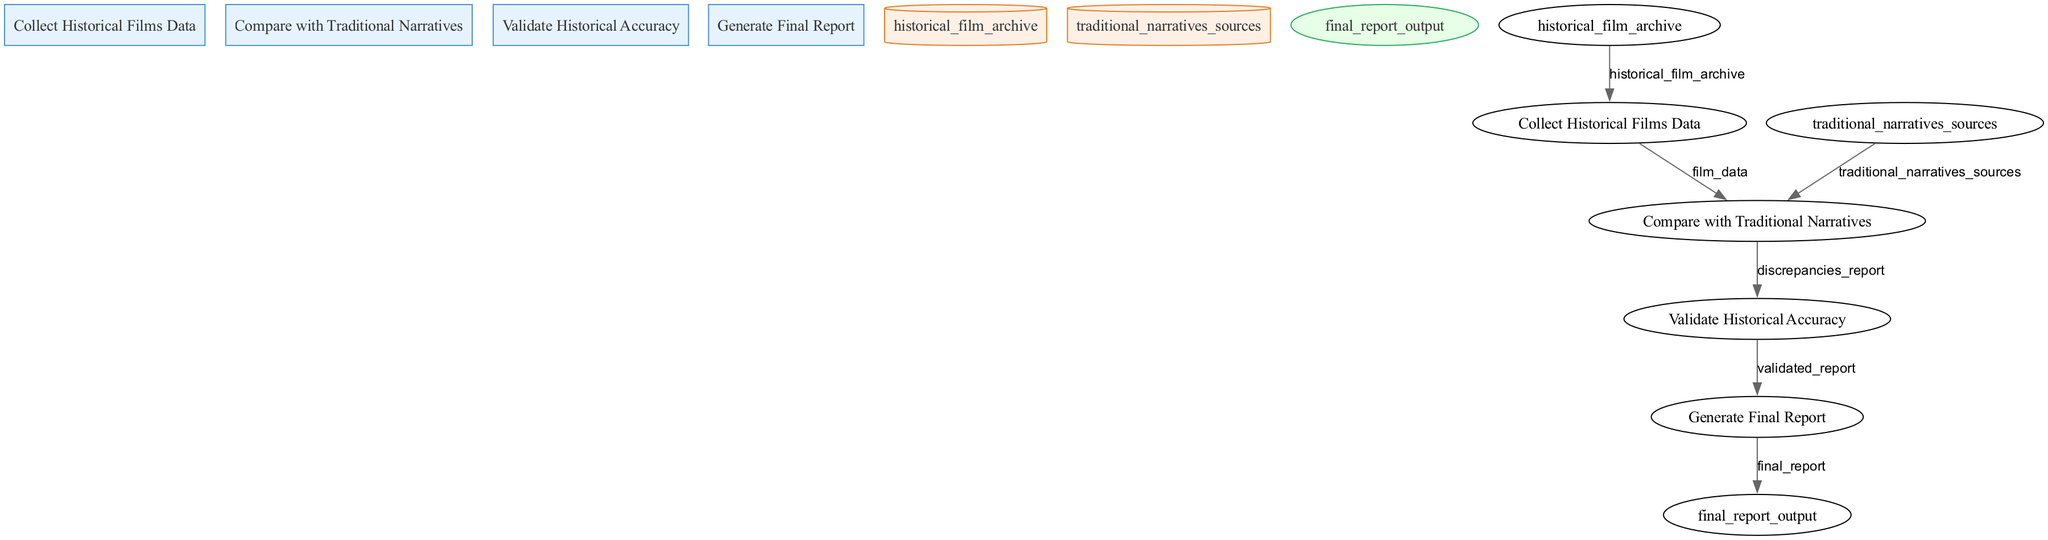What is the output of process 3? Process 3, "Validate Historical Accuracy," produces an output termed "validated_report." This is the result of checking discrepancies found in the previous step for historical accuracy.
Answer: validated_report How many data stores are present in the diagram? The diagram contains two data stores: "historical_film_archive" and "traditional_narratives_sources." These are the locations where data is stored for processing.
Answer: 2 What is the input for process 2? Process 2, "Compare with Traditional Narratives," requires two inputs: "film_data," which comes from process 1, and "traditional_narratives_sources," which is the data store.
Answer: film_data and traditional_narratives_sources Which process generates the final report? The final report is generated by process 4, "Generate Final Report," which compiles information from the validated report created in process 3.
Answer: Generate Final Report What type of node is "historical_film_archive"? "historical_film_archive" is categorized as a data store, indicated by its cylindrical shape in the diagram. This store holds information on historical films.
Answer: data store What would you find in the validated report? The validated report contains the results of the validation process, which assesses the accuracy of historical films against traditional narratives.
Answer: accuracy results What is the purpose of process 1? Process 1, "Collect Historical Films Data," is directed towards gathering data relating to historical films, which includes plot summaries and production details.
Answer: Gathering data What is the relationship between process 2 and the data store "traditional_narratives_sources"? Process 2 utilizes "traditional_narratives_sources" as an input, indicating that it compares the data from this store against film data to identify discrepancies.
Answer: input relationship How does the final report get produced from the previous processes? The final report is produced by process 4, which takes the "validated_report" from process 3 as its input and compiles the findings into the final output, ready for review.
Answer: process 4 